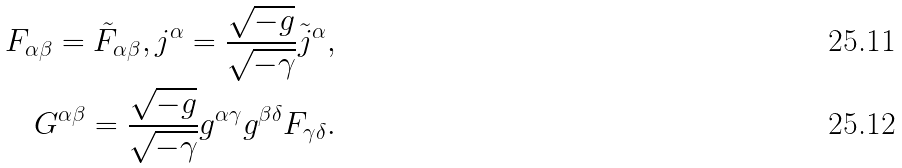<formula> <loc_0><loc_0><loc_500><loc_500>F _ { \alpha \beta } = \tilde { F } _ { \alpha \beta } , j ^ { \alpha } = \frac { \sqrt { - g } } { \sqrt { - \gamma } } \tilde { j } ^ { \alpha } , \\ G ^ { \alpha \beta } = \frac { \sqrt { - g } } { \sqrt { - \gamma } } g ^ { \alpha \gamma } g ^ { \beta \delta } F _ { \gamma \delta } .</formula> 